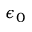Convert formula to latex. <formula><loc_0><loc_0><loc_500><loc_500>\epsilon _ { 0 }</formula> 